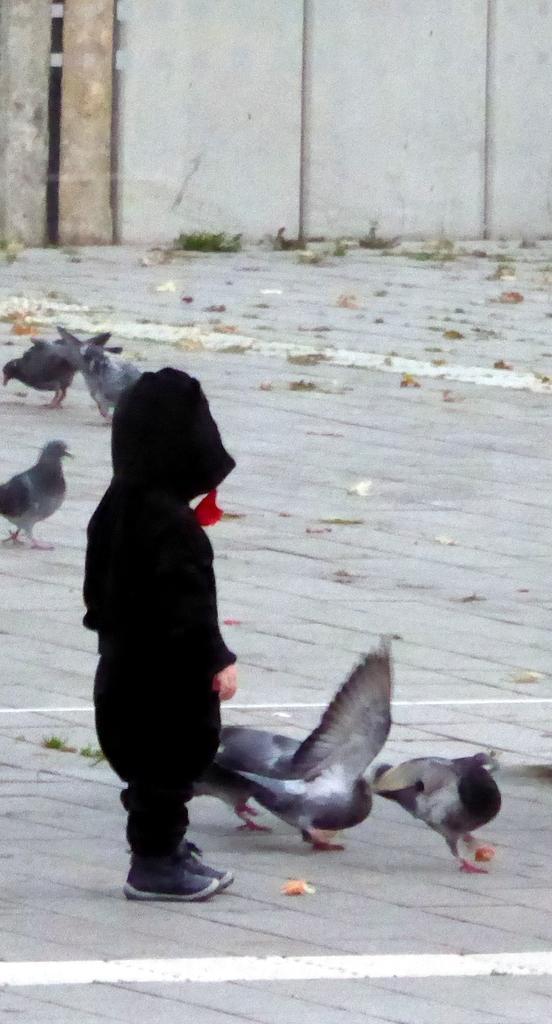Can you describe this image briefly? As we can see in the image there is a child wearing black color jacket and there are birds. In the background there is a building. 